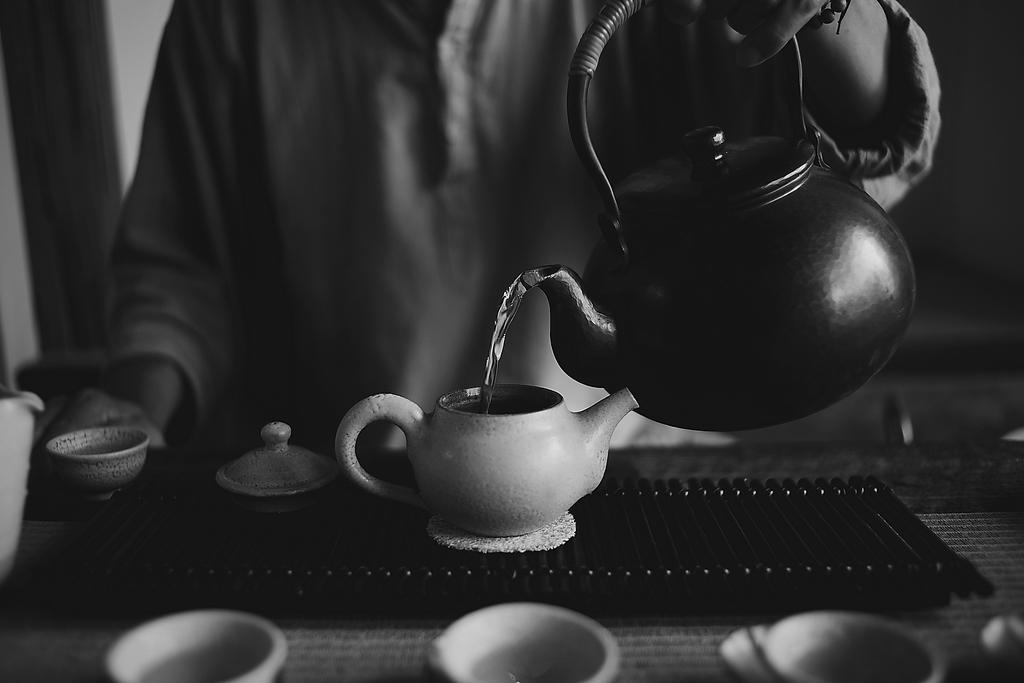What is the color scheme of the image? The image is black and white. Who or what is the main subject in the image? There is a person in the image. What is the person doing in the image? The person is holding a kettle and pouring water from one kettle to another. What is the person standing near in the image? There is a table in the image. What items can be seen on the table? There are cups, a kettle, a lid, and other objects on the table. Is there a house visible in the image? No, there is no house present in the image. Can you see a field in the background of the image? No, there is no field visible in the image. 